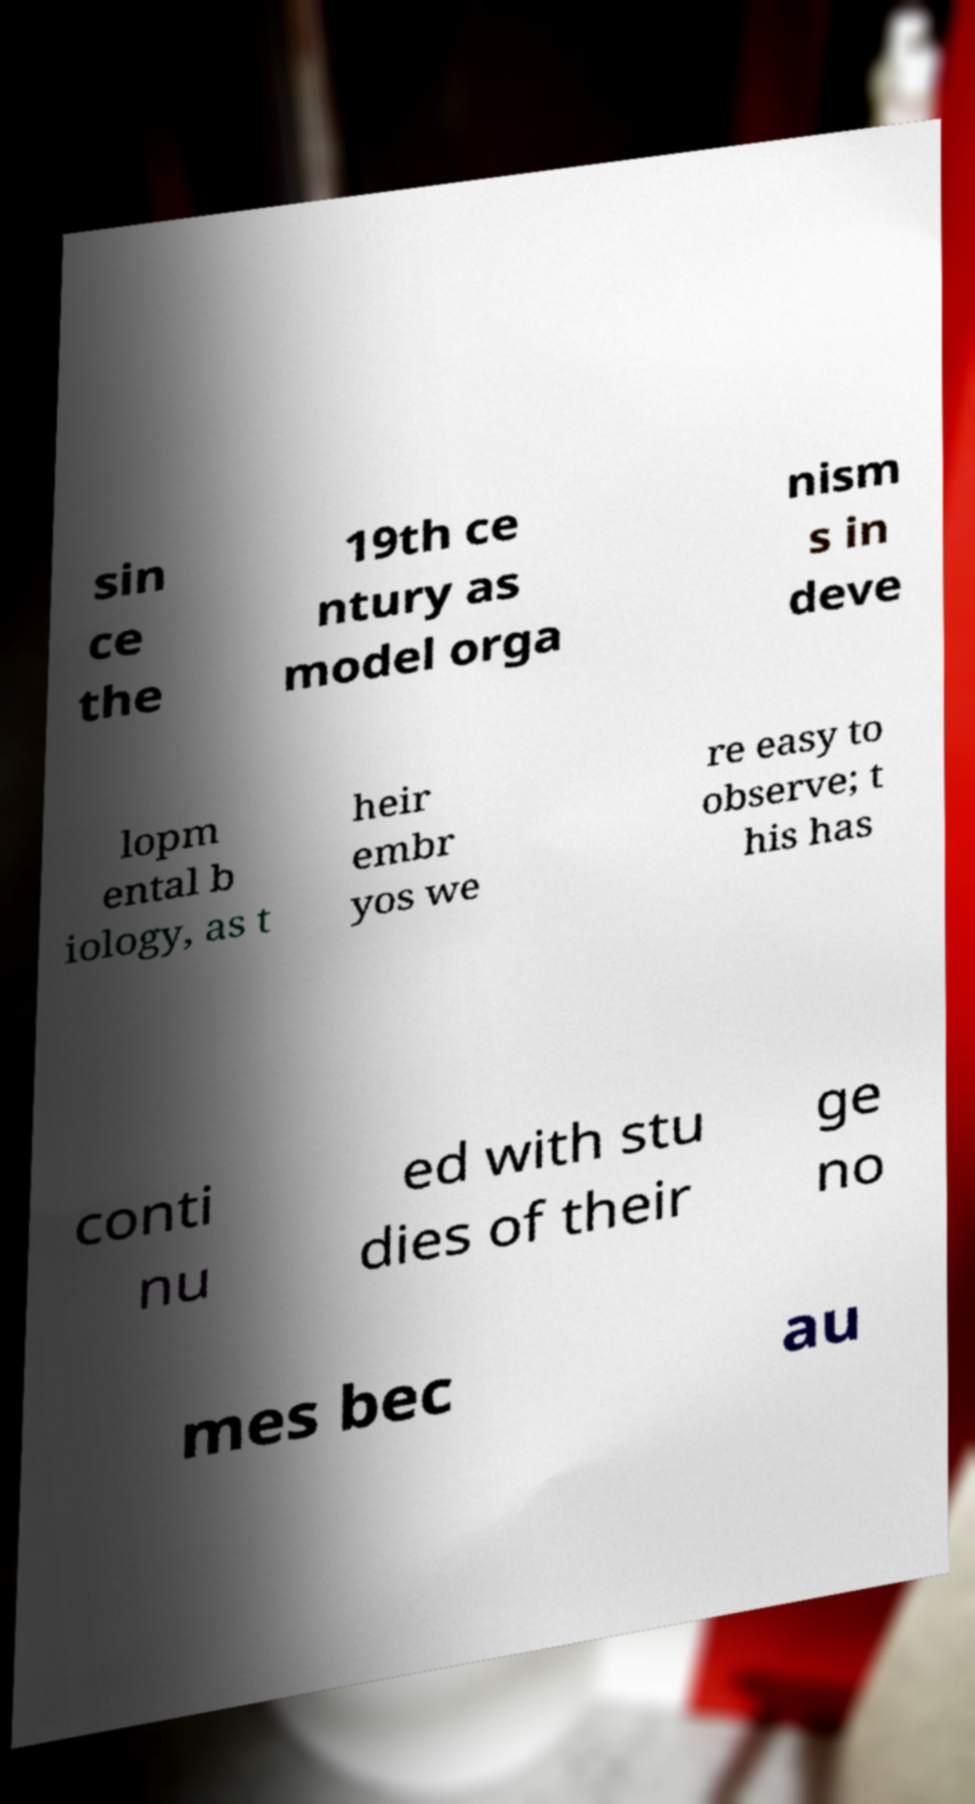There's text embedded in this image that I need extracted. Can you transcribe it verbatim? sin ce the 19th ce ntury as model orga nism s in deve lopm ental b iology, as t heir embr yos we re easy to observe; t his has conti nu ed with stu dies of their ge no mes bec au 